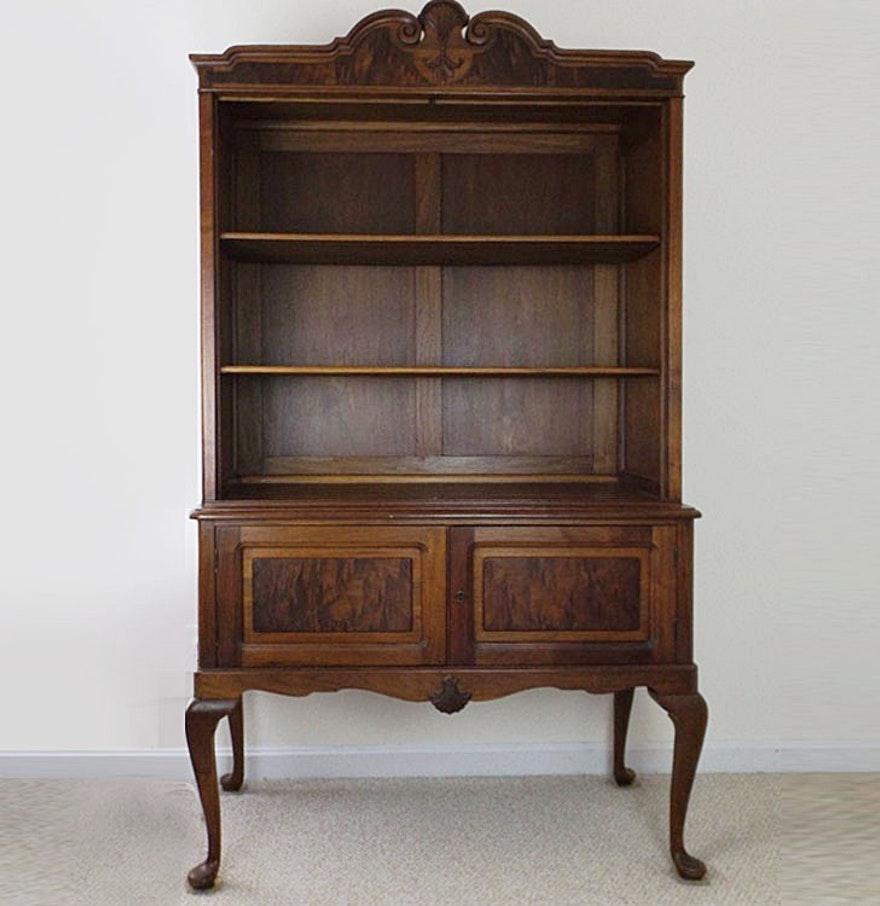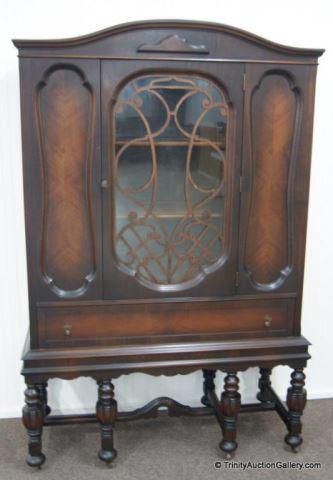The first image is the image on the left, the second image is the image on the right. For the images shown, is this caption "There are dishes in one of the cabinets." true? Answer yes or no. No. 